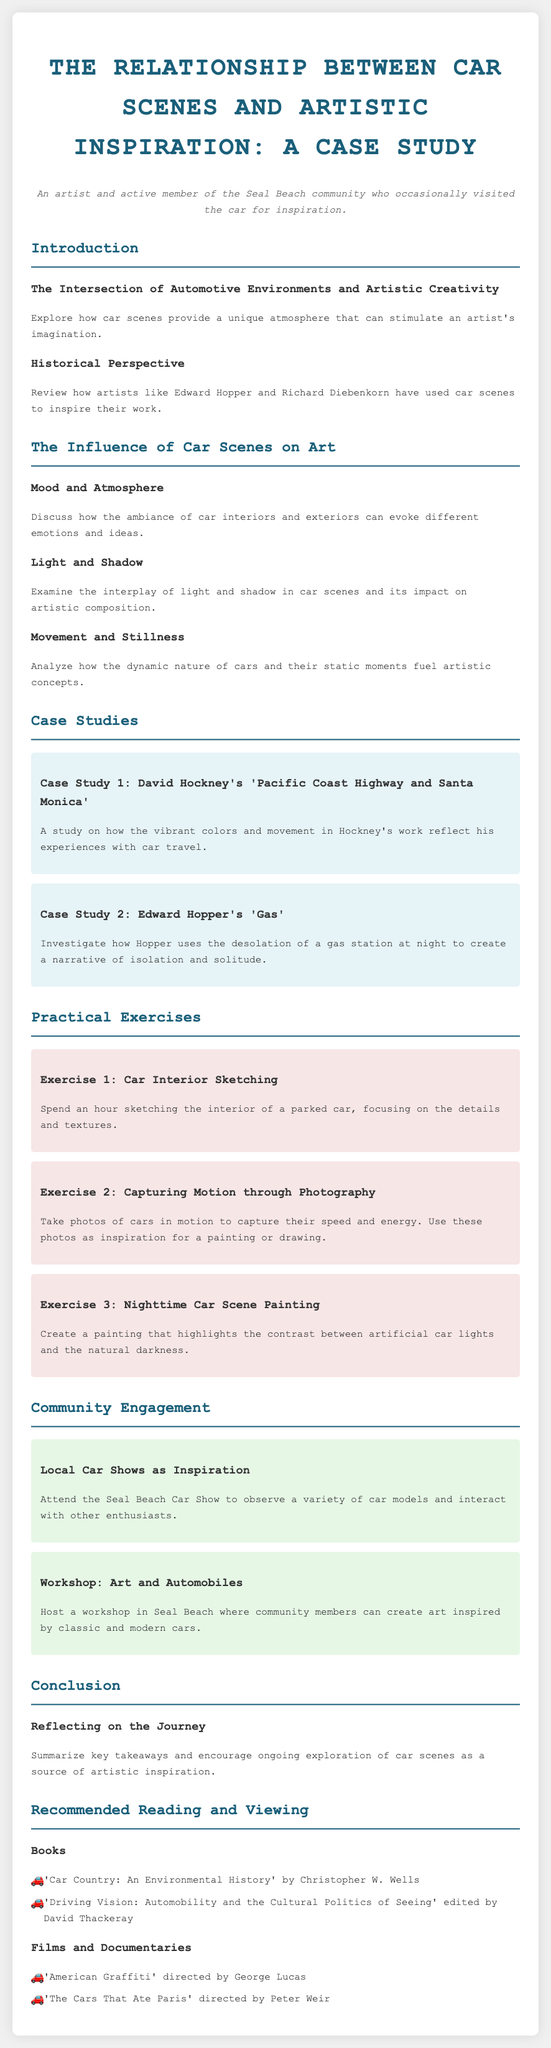What is the title of the syllabus? The title is stated at the top of the document and provides the main topic of study.
Answer: The Relationship between Car Scenes and Artistic Inspiration: A Case Study Who are the artists mentioned in the historical perspective section? The document lists two artists who have used car scenes for inspiration in their work.
Answer: Edward Hopper and Richard Diebenkorn How many practical exercises are included in the syllabus? The number of exercises is specified in the section dedicated to practical activities for artists.
Answer: Three What painting by David Hockney is discussed in the case studies? This question focuses on identifying the specific artwork mentioned in the syllabus under case studies.
Answer: Pacific Coast Highway and Santa Monica What is one of the recommended films to watch? This inquiry aims to find one of the films listed under recommended reading and viewing as an additional resource.
Answer: American Graffiti What type of community engagement activity is suggested involving local cars? The syllabus describes community activities designed to inspire artists through interaction with cars in a local setting.
Answer: Local Car Shows as Inspiration What mood element is explored in the section titled "Mood and Atmosphere"? This question targets understanding the specific themes discussed in relation to car scenes and emotions.
Answer: Ambiance What painting technique is the focus of Exercise 2? This question examines the type of creative method suggested in the practical exercises section.
Answer: Photography How does the syllabus conclude? This question asks for a summary understanding of the last section of the document, emphasizing what it covers.
Answer: Reflecting on the Journey 